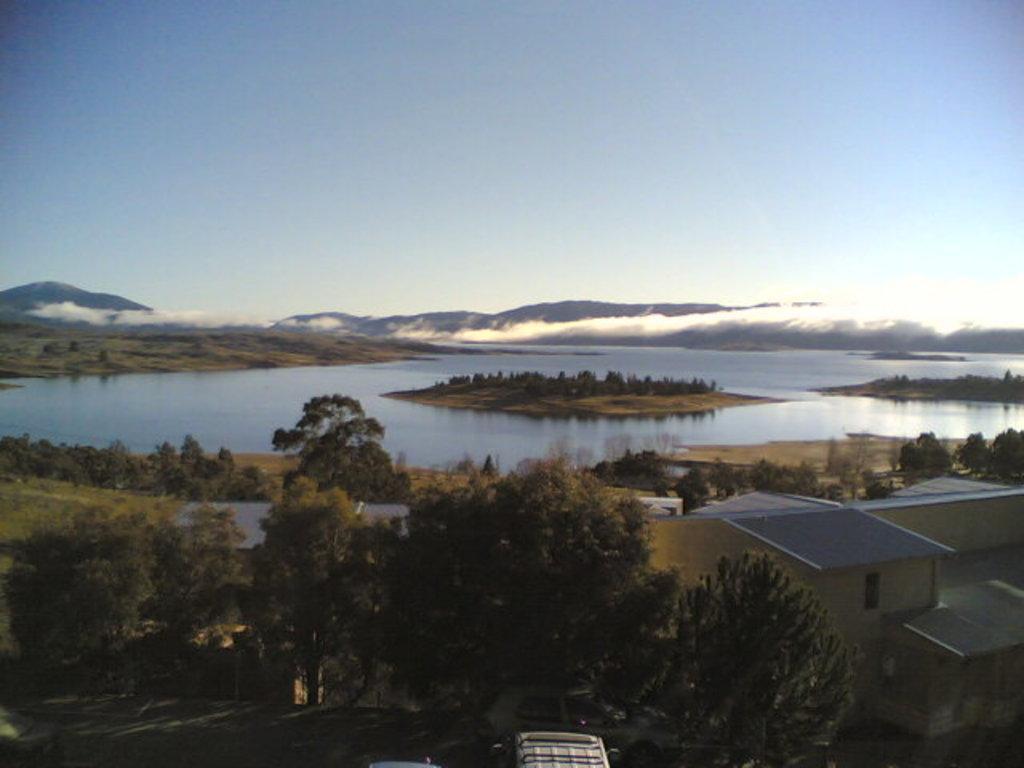In one or two sentences, can you explain what this image depicts? In this picture we can see the river. In the background we can see the mountains. At bottom we can see the vehicles which is parked near to the trees. On the right we can see the buildings. At the top there is a sky. 